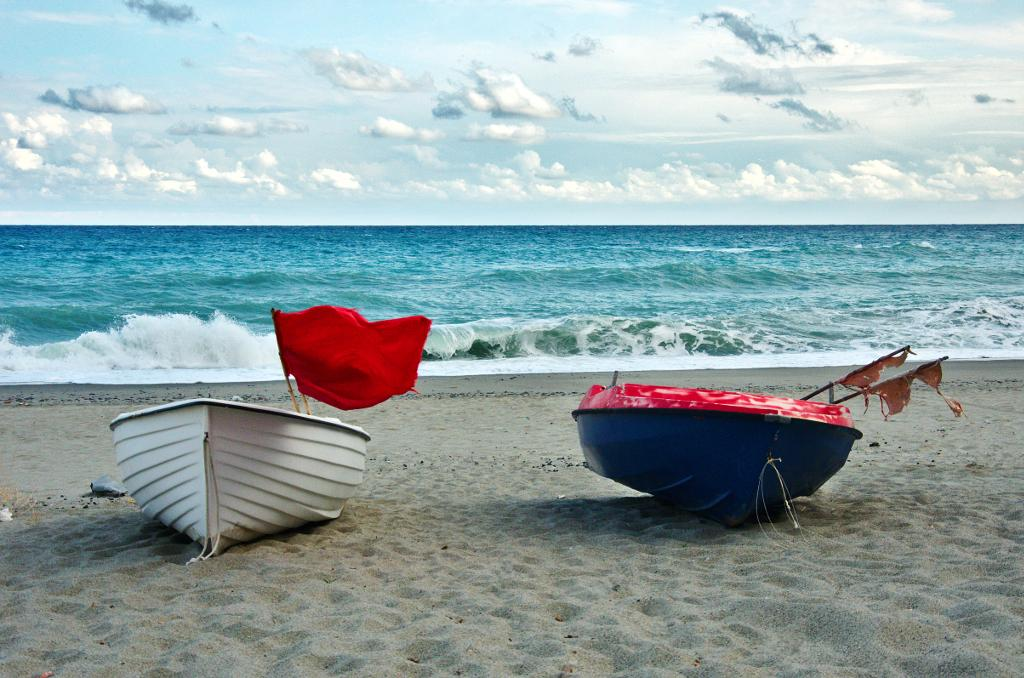How many boats can be seen in the image? There are two boats in the image. Where are the boats located? The boats are on the seashore. What else can be seen in the image besides the boats? There is water visible in the image. What is visible in the background of the image? The sky is visible in the background of the image. What type of knee surgery is being performed on the boat in the image? There is no knee surgery or any reference to a knee in the image; it features two boats on the seashore. 